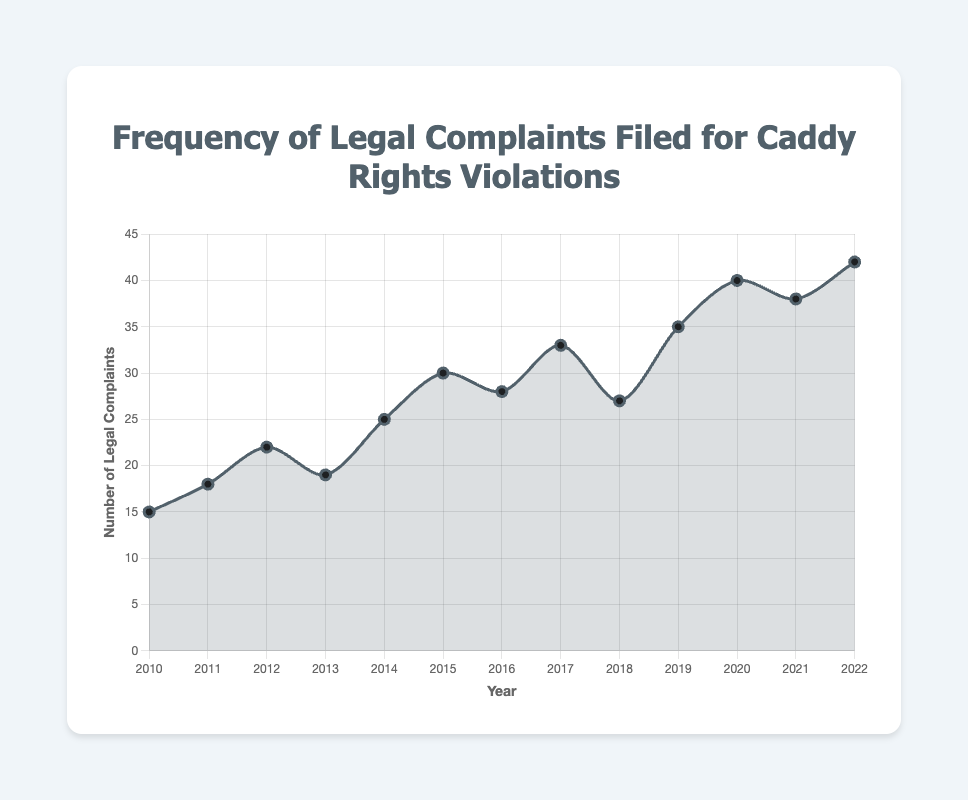What is the trend in the number of legal complaints from 2010 to 2022? The overall trend from 2010 to 2022 shows an increase in the number of legal complaints filed. Although there are fluctuations, the general direction is upward. For instance, the number of complaints rose from 15 in 2010 to 42 in 2022.
Answer: Increasing In which year did the number of legal complaints experience the largest single-year increase? To find this, look at the difference in complaints between consecutive years. The largest increase happens from 2019 (35 complaints) to 2020 (40 complaints), which is an increase of 5 complaints.
Answer: 2020 What was the total number of legal complaints filed from 2015 to 2018? Sum the number of legal complaints for the years 2015, 2016, 2017, and 2018: 30 (2015) + 28 (2016) + 33 (2017) + 27 (2018) = 118.
Answer: 118 Which year had fewer legal complaints, 2013 or 2018? Compare the number of legal complaints for the years 2013 and 2018. In 2013, there were 19 complaints; in 2018, there were 27 complaints. Therefore, 2013 had fewer complaints.
Answer: 2013 What is the average number of legal complaints filed per year from 2010 to 2022? Sum all legal complaints from 2010 to 2022 and then divide by the number of years, which is 13. Sum: 15 + 18 + 22 + 19 + 25 + 30 + 28 + 33 + 27 + 35 + 40 + 38 + 42 = 372. Average: 372 / 13 ≈ 28.62.
Answer: 28.62 Does the chart show any period of consistent decline in legal complaints? Identify any consecutive years where the number of legal complaints decreased each year. From 2020 to 2021, the complaints decreased from 40 to 38. However, this is just a single-year decline, not a consistent multi-year decline.
Answer: No In which year did the number of legal complaints return to its previous year's level (equal values)? Check if there are any years where the number of legal complaints repeated. There are no such cases in the given data set, as all values are unique for each year.
Answer: None How many more legal complaints were filed in 2022 compared to 2010? Subtract the number of legal complaints in 2010 from that in 2022. Hence, 42 (2022) - 15 (2010) = 27.
Answer: 27 Which year had a higher number of legal complaints, 2011 or 2012? Compare the number of legal complaints in 2011 and 2012. In 2011, there were 18 complaints; in 2012, there were 22 complaints. Therefore, 2012 had a higher number of complaints.
Answer: 2012 